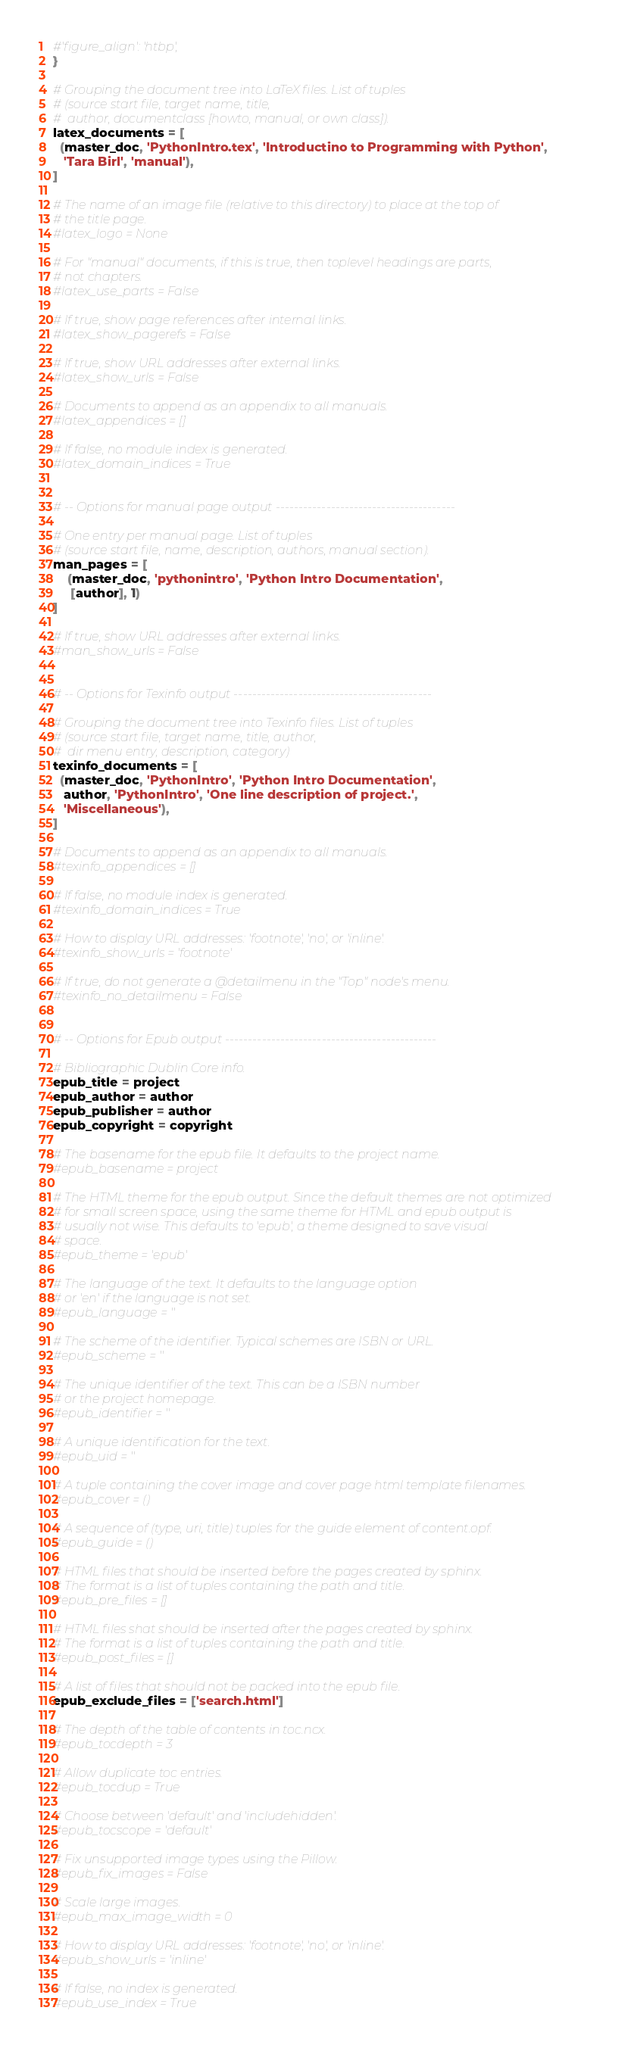Convert code to text. <code><loc_0><loc_0><loc_500><loc_500><_Python_>#'figure_align': 'htbp',
}

# Grouping the document tree into LaTeX files. List of tuples
# (source start file, target name, title,
#  author, documentclass [howto, manual, or own class]).
latex_documents = [
  (master_doc, 'PythonIntro.tex', 'Introductino to Programming with Python',
   'Tara Birl', 'manual'),
]

# The name of an image file (relative to this directory) to place at the top of
# the title page.
#latex_logo = None

# For "manual" documents, if this is true, then toplevel headings are parts,
# not chapters.
#latex_use_parts = False

# If true, show page references after internal links.
#latex_show_pagerefs = False

# If true, show URL addresses after external links.
#latex_show_urls = False

# Documents to append as an appendix to all manuals.
#latex_appendices = []

# If false, no module index is generated.
#latex_domain_indices = True


# -- Options for manual page output ---------------------------------------

# One entry per manual page. List of tuples
# (source start file, name, description, authors, manual section).
man_pages = [
    (master_doc, 'pythonintro', 'Python Intro Documentation',
     [author], 1)
]

# If true, show URL addresses after external links.
#man_show_urls = False


# -- Options for Texinfo output -------------------------------------------

# Grouping the document tree into Texinfo files. List of tuples
# (source start file, target name, title, author,
#  dir menu entry, description, category)
texinfo_documents = [
  (master_doc, 'PythonIntro', 'Python Intro Documentation',
   author, 'PythonIntro', 'One line description of project.',
   'Miscellaneous'),
]

# Documents to append as an appendix to all manuals.
#texinfo_appendices = []

# If false, no module index is generated.
#texinfo_domain_indices = True

# How to display URL addresses: 'footnote', 'no', or 'inline'.
#texinfo_show_urls = 'footnote'

# If true, do not generate a @detailmenu in the "Top" node's menu.
#texinfo_no_detailmenu = False


# -- Options for Epub output ----------------------------------------------

# Bibliographic Dublin Core info.
epub_title = project
epub_author = author
epub_publisher = author
epub_copyright = copyright

# The basename for the epub file. It defaults to the project name.
#epub_basename = project

# The HTML theme for the epub output. Since the default themes are not optimized
# for small screen space, using the same theme for HTML and epub output is
# usually not wise. This defaults to 'epub', a theme designed to save visual
# space.
#epub_theme = 'epub'

# The language of the text. It defaults to the language option
# or 'en' if the language is not set.
#epub_language = ''

# The scheme of the identifier. Typical schemes are ISBN or URL.
#epub_scheme = ''

# The unique identifier of the text. This can be a ISBN number
# or the project homepage.
#epub_identifier = ''

# A unique identification for the text.
#epub_uid = ''

# A tuple containing the cover image and cover page html template filenames.
#epub_cover = ()

# A sequence of (type, uri, title) tuples for the guide element of content.opf.
#epub_guide = ()

# HTML files that should be inserted before the pages created by sphinx.
# The format is a list of tuples containing the path and title.
#epub_pre_files = []

# HTML files shat should be inserted after the pages created by sphinx.
# The format is a list of tuples containing the path and title.
#epub_post_files = []

# A list of files that should not be packed into the epub file.
epub_exclude_files = ['search.html']

# The depth of the table of contents in toc.ncx.
#epub_tocdepth = 3

# Allow duplicate toc entries.
#epub_tocdup = True

# Choose between 'default' and 'includehidden'.
#epub_tocscope = 'default'

# Fix unsupported image types using the Pillow.
#epub_fix_images = False

# Scale large images.
#epub_max_image_width = 0

# How to display URL addresses: 'footnote', 'no', or 'inline'.
#epub_show_urls = 'inline'

# If false, no index is generated.
#epub_use_index = True
</code> 